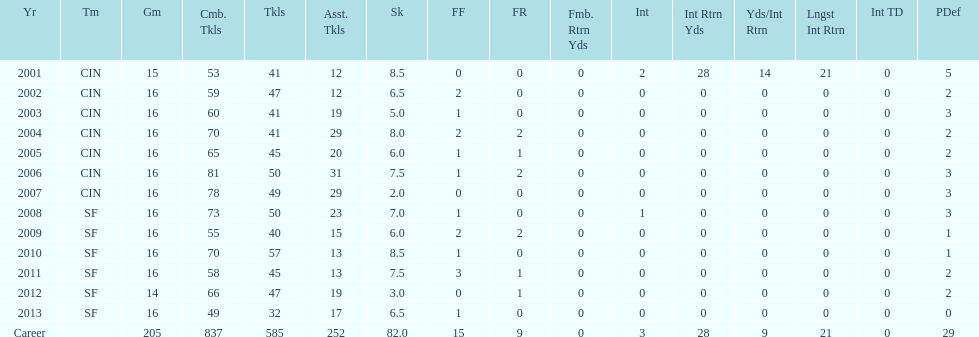How many fumble recoveries did this player have in 2004? 2. 